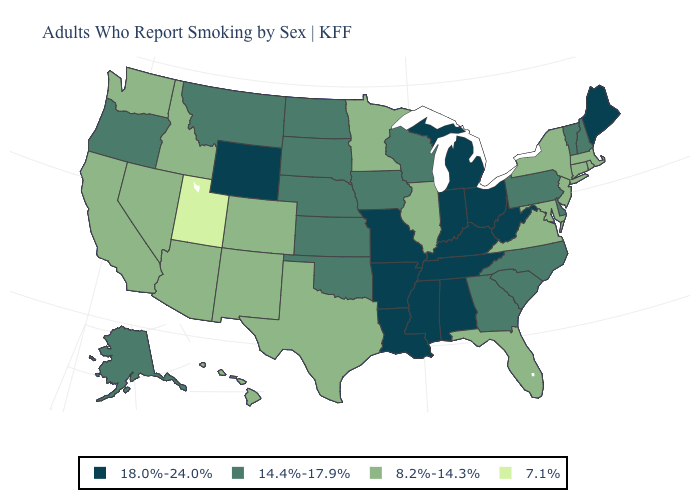Does Alaska have the same value as Alabama?
Concise answer only. No. What is the value of Missouri?
Concise answer only. 18.0%-24.0%. Name the states that have a value in the range 18.0%-24.0%?
Quick response, please. Alabama, Arkansas, Indiana, Kentucky, Louisiana, Maine, Michigan, Mississippi, Missouri, Ohio, Tennessee, West Virginia, Wyoming. Name the states that have a value in the range 14.4%-17.9%?
Be succinct. Alaska, Delaware, Georgia, Iowa, Kansas, Montana, Nebraska, New Hampshire, North Carolina, North Dakota, Oklahoma, Oregon, Pennsylvania, South Carolina, South Dakota, Vermont, Wisconsin. What is the lowest value in states that border California?
Quick response, please. 8.2%-14.3%. What is the value of Connecticut?
Be succinct. 8.2%-14.3%. Does Illinois have the lowest value in the USA?
Keep it brief. No. Does Utah have the lowest value in the USA?
Short answer required. Yes. Does California have the highest value in the West?
Concise answer only. No. Is the legend a continuous bar?
Concise answer only. No. What is the value of North Carolina?
Give a very brief answer. 14.4%-17.9%. What is the value of Washington?
Give a very brief answer. 8.2%-14.3%. Which states have the lowest value in the West?
Keep it brief. Utah. Among the states that border Utah , does Idaho have the lowest value?
Keep it brief. Yes. 